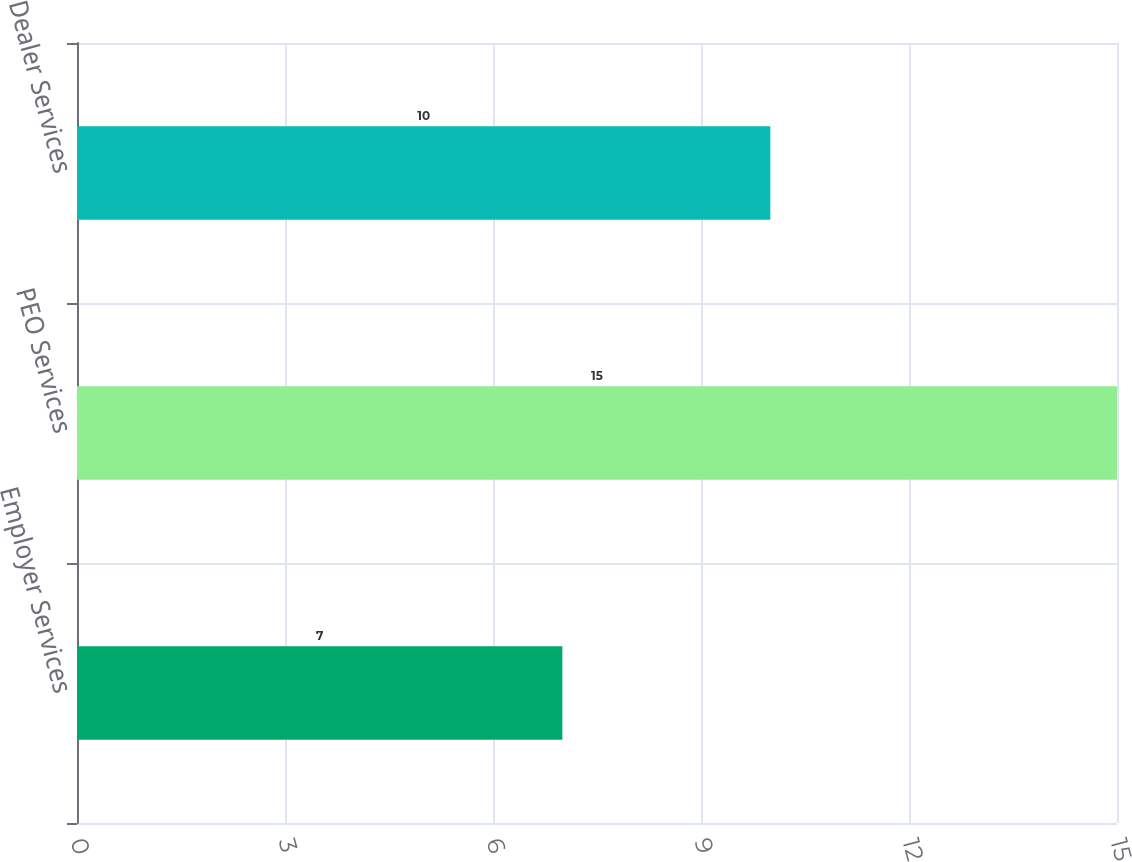Convert chart. <chart><loc_0><loc_0><loc_500><loc_500><bar_chart><fcel>Employer Services<fcel>PEO Services<fcel>Dealer Services<nl><fcel>7<fcel>15<fcel>10<nl></chart> 